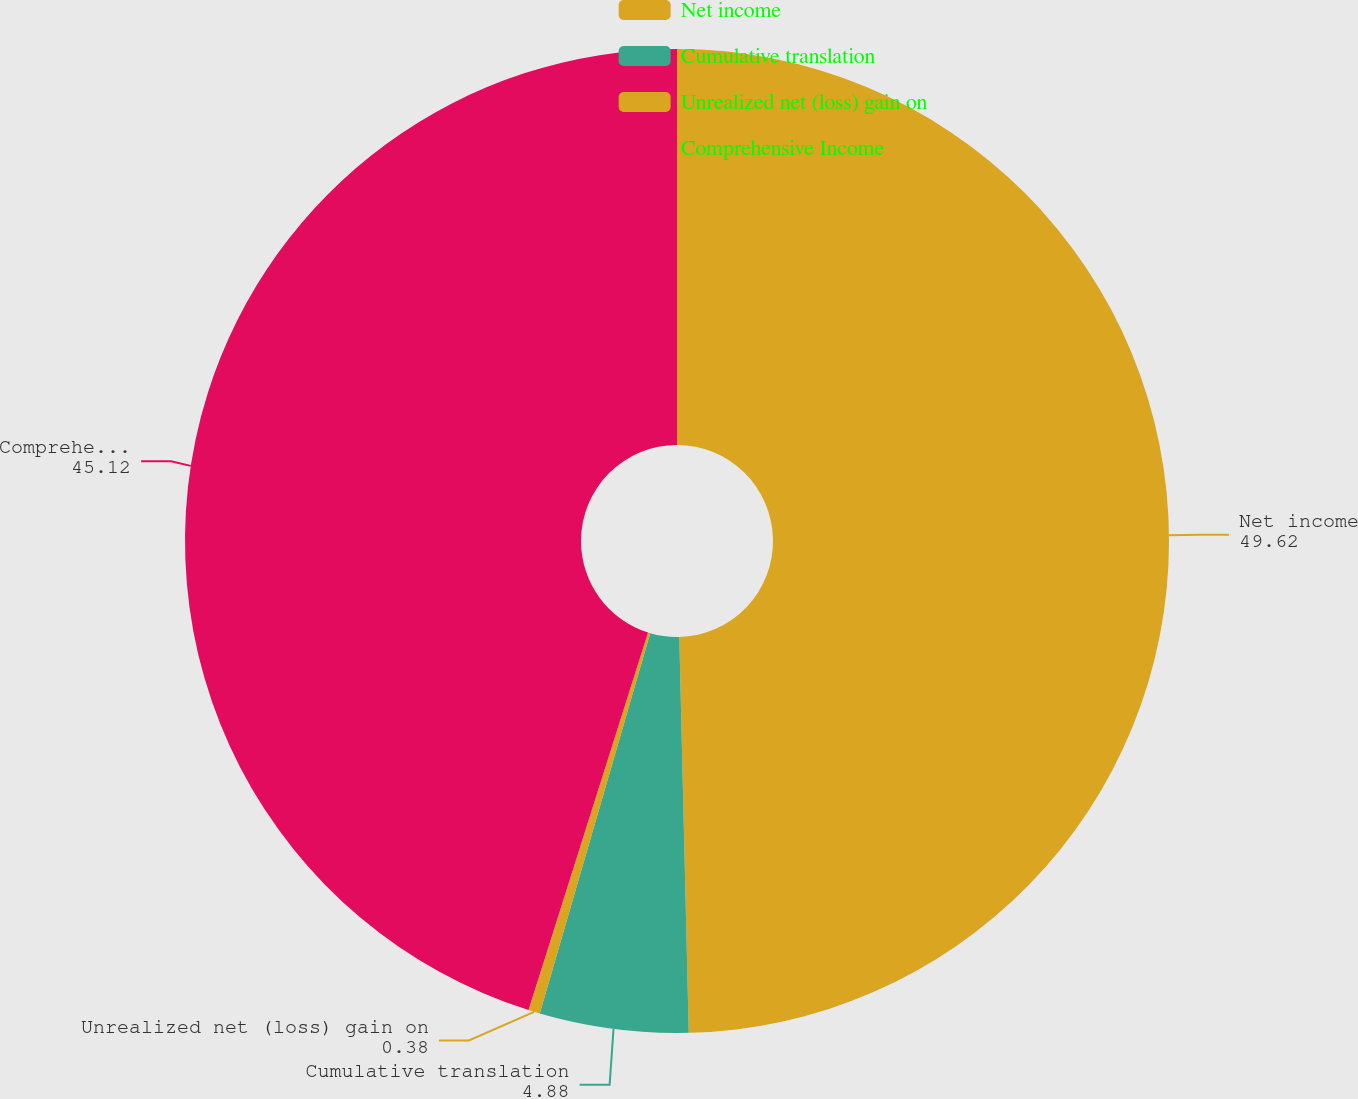Convert chart. <chart><loc_0><loc_0><loc_500><loc_500><pie_chart><fcel>Net income<fcel>Cumulative translation<fcel>Unrealized net (loss) gain on<fcel>Comprehensive Income<nl><fcel>49.62%<fcel>4.88%<fcel>0.38%<fcel>45.12%<nl></chart> 